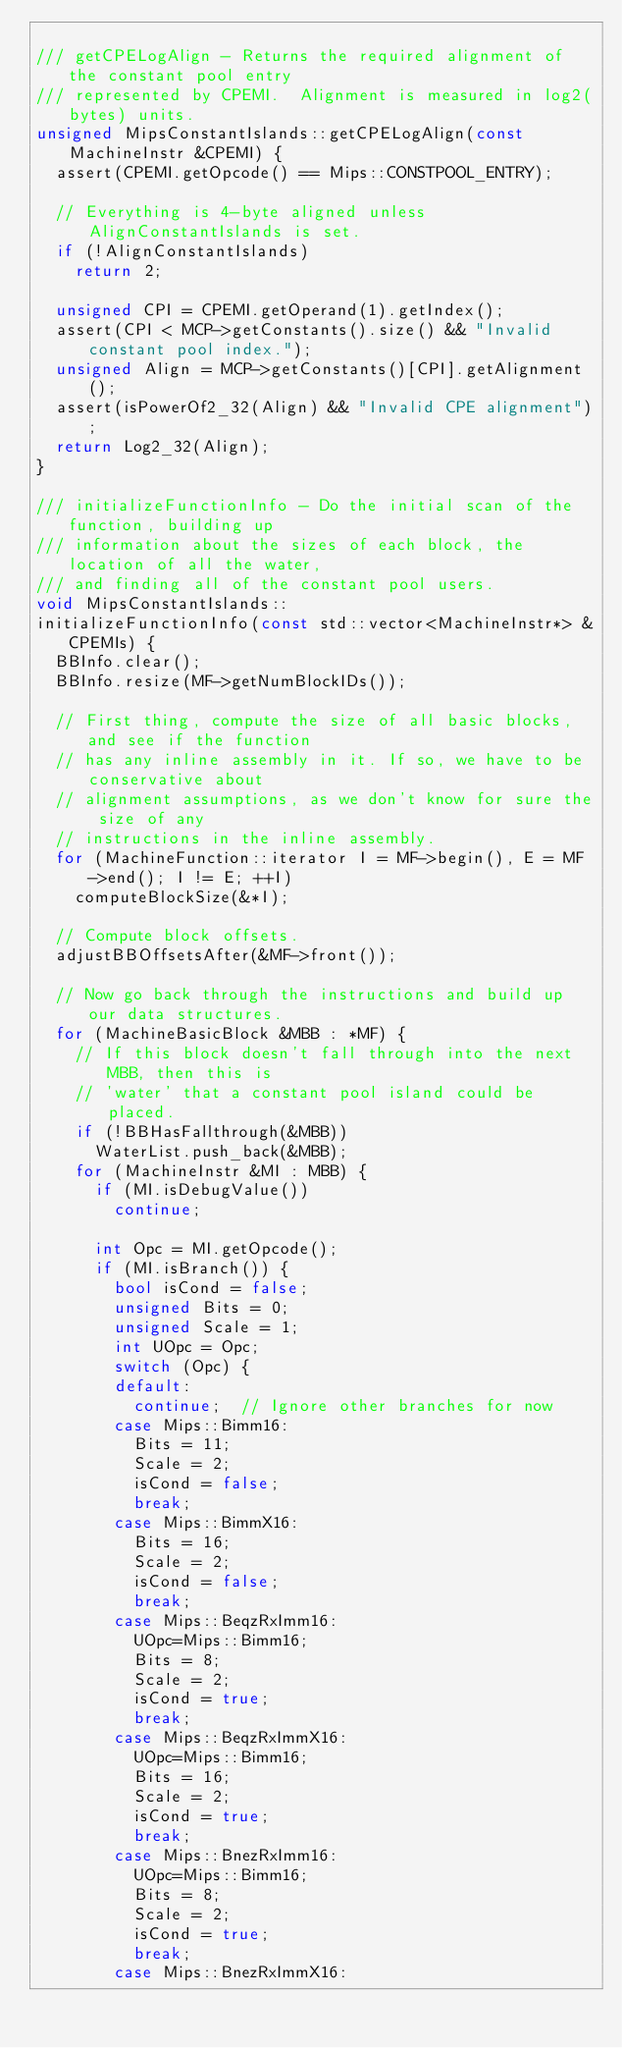<code> <loc_0><loc_0><loc_500><loc_500><_C++_>
/// getCPELogAlign - Returns the required alignment of the constant pool entry
/// represented by CPEMI.  Alignment is measured in log2(bytes) units.
unsigned MipsConstantIslands::getCPELogAlign(const MachineInstr &CPEMI) {
  assert(CPEMI.getOpcode() == Mips::CONSTPOOL_ENTRY);

  // Everything is 4-byte aligned unless AlignConstantIslands is set.
  if (!AlignConstantIslands)
    return 2;

  unsigned CPI = CPEMI.getOperand(1).getIndex();
  assert(CPI < MCP->getConstants().size() && "Invalid constant pool index.");
  unsigned Align = MCP->getConstants()[CPI].getAlignment();
  assert(isPowerOf2_32(Align) && "Invalid CPE alignment");
  return Log2_32(Align);
}

/// initializeFunctionInfo - Do the initial scan of the function, building up
/// information about the sizes of each block, the location of all the water,
/// and finding all of the constant pool users.
void MipsConstantIslands::
initializeFunctionInfo(const std::vector<MachineInstr*> &CPEMIs) {
  BBInfo.clear();
  BBInfo.resize(MF->getNumBlockIDs());

  // First thing, compute the size of all basic blocks, and see if the function
  // has any inline assembly in it. If so, we have to be conservative about
  // alignment assumptions, as we don't know for sure the size of any
  // instructions in the inline assembly.
  for (MachineFunction::iterator I = MF->begin(), E = MF->end(); I != E; ++I)
    computeBlockSize(&*I);

  // Compute block offsets.
  adjustBBOffsetsAfter(&MF->front());

  // Now go back through the instructions and build up our data structures.
  for (MachineBasicBlock &MBB : *MF) {
    // If this block doesn't fall through into the next MBB, then this is
    // 'water' that a constant pool island could be placed.
    if (!BBHasFallthrough(&MBB))
      WaterList.push_back(&MBB);
    for (MachineInstr &MI : MBB) {
      if (MI.isDebugValue())
        continue;

      int Opc = MI.getOpcode();
      if (MI.isBranch()) {
        bool isCond = false;
        unsigned Bits = 0;
        unsigned Scale = 1;
        int UOpc = Opc;
        switch (Opc) {
        default:
          continue;  // Ignore other branches for now
        case Mips::Bimm16:
          Bits = 11;
          Scale = 2;
          isCond = false;
          break;
        case Mips::BimmX16:
          Bits = 16;
          Scale = 2;
          isCond = false;
          break;
        case Mips::BeqzRxImm16:
          UOpc=Mips::Bimm16;
          Bits = 8;
          Scale = 2;
          isCond = true;
          break;
        case Mips::BeqzRxImmX16:
          UOpc=Mips::Bimm16;
          Bits = 16;
          Scale = 2;
          isCond = true;
          break;
        case Mips::BnezRxImm16:
          UOpc=Mips::Bimm16;
          Bits = 8;
          Scale = 2;
          isCond = true;
          break;
        case Mips::BnezRxImmX16:</code> 